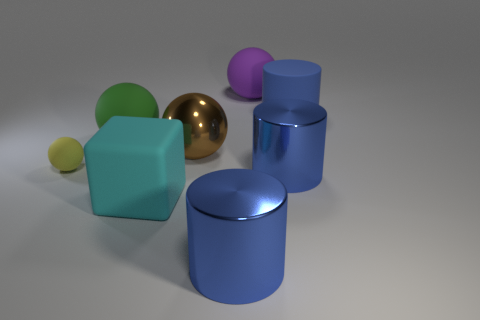What number of metal cylinders have the same color as the big matte cylinder?
Offer a very short reply. 2. The large blue cylinder that is behind the large brown sphere that is in front of the purple rubber ball is made of what material?
Ensure brevity in your answer.  Rubber. What number of objects are big green rubber balls in front of the purple thing or large matte objects that are to the left of the large purple object?
Keep it short and to the point. 2. How big is the yellow rubber ball behind the blue cylinder left of the metal cylinder behind the block?
Your answer should be compact. Small. Is the number of big blue cylinders that are left of the big metal ball the same as the number of cylinders?
Keep it short and to the point. No. Is there any other thing that is the same shape as the large cyan matte object?
Make the answer very short. No. Is the shape of the purple object the same as the big rubber thing that is in front of the metallic ball?
Give a very brief answer. No. There is another green rubber thing that is the same shape as the tiny matte thing; what is its size?
Provide a succinct answer. Large. What number of other things are made of the same material as the big purple thing?
Offer a very short reply. 4. What is the small yellow ball made of?
Your answer should be compact. Rubber. 